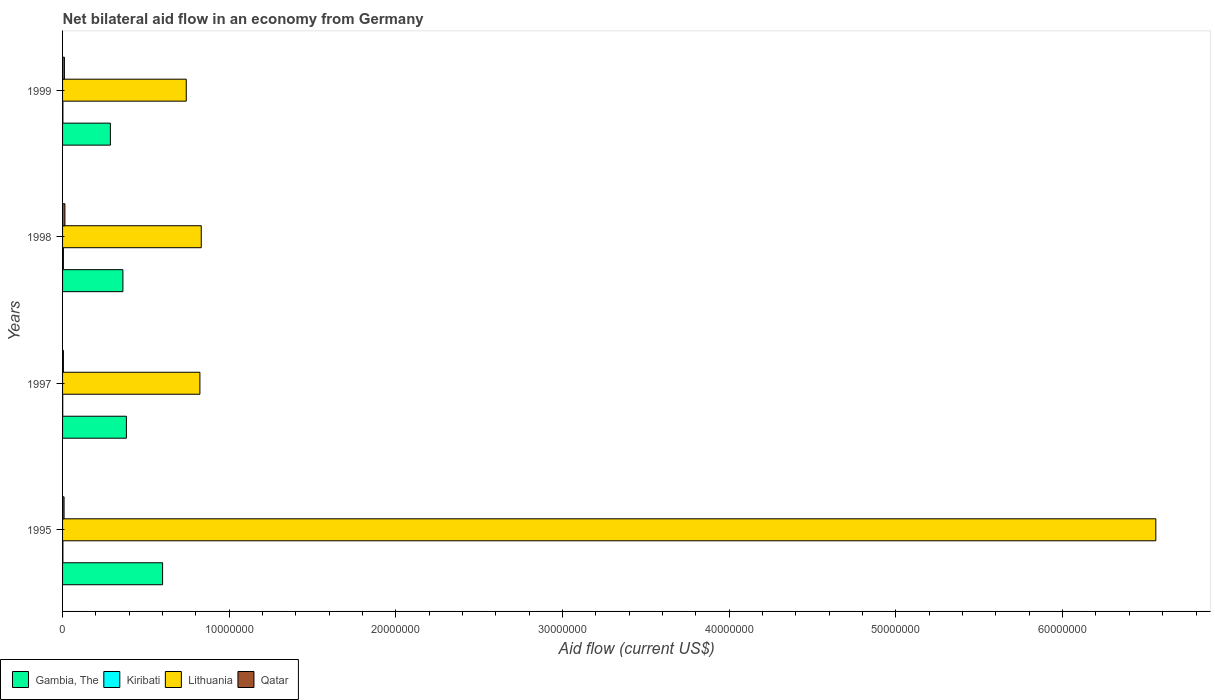How many groups of bars are there?
Give a very brief answer. 4. How many bars are there on the 3rd tick from the bottom?
Your response must be concise. 4. What is the label of the 4th group of bars from the top?
Give a very brief answer. 1995. In how many cases, is the number of bars for a given year not equal to the number of legend labels?
Ensure brevity in your answer.  0. What is the net bilateral aid flow in Kiribati in 1995?
Your response must be concise. 2.00e+04. In which year was the net bilateral aid flow in Lithuania maximum?
Keep it short and to the point. 1995. In which year was the net bilateral aid flow in Kiribati minimum?
Offer a very short reply. 1997. What is the total net bilateral aid flow in Gambia, The in the graph?
Your answer should be very brief. 1.63e+07. What is the difference between the net bilateral aid flow in Gambia, The in 1995 and that in 1999?
Give a very brief answer. 3.13e+06. What is the average net bilateral aid flow in Lithuania per year?
Provide a short and direct response. 2.24e+07. In the year 1998, what is the difference between the net bilateral aid flow in Lithuania and net bilateral aid flow in Qatar?
Your response must be concise. 8.18e+06. In how many years, is the net bilateral aid flow in Qatar greater than 4000000 US$?
Give a very brief answer. 0. What is the ratio of the net bilateral aid flow in Qatar in 1995 to that in 1997?
Provide a short and direct response. 1.8. Is the difference between the net bilateral aid flow in Lithuania in 1998 and 1999 greater than the difference between the net bilateral aid flow in Qatar in 1998 and 1999?
Offer a terse response. Yes. What is the difference between the highest and the second highest net bilateral aid flow in Lithuania?
Ensure brevity in your answer.  5.73e+07. What is the difference between the highest and the lowest net bilateral aid flow in Lithuania?
Keep it short and to the point. 5.82e+07. In how many years, is the net bilateral aid flow in Kiribati greater than the average net bilateral aid flow in Kiribati taken over all years?
Make the answer very short. 1. What does the 4th bar from the top in 1997 represents?
Provide a succinct answer. Gambia, The. What does the 4th bar from the bottom in 1998 represents?
Provide a short and direct response. Qatar. Is it the case that in every year, the sum of the net bilateral aid flow in Qatar and net bilateral aid flow in Gambia, The is greater than the net bilateral aid flow in Kiribati?
Provide a short and direct response. Yes. How many years are there in the graph?
Your answer should be very brief. 4. What is the difference between two consecutive major ticks on the X-axis?
Your answer should be very brief. 1.00e+07. Are the values on the major ticks of X-axis written in scientific E-notation?
Provide a succinct answer. No. Does the graph contain any zero values?
Keep it short and to the point. No. Does the graph contain grids?
Give a very brief answer. No. How many legend labels are there?
Your answer should be very brief. 4. What is the title of the graph?
Ensure brevity in your answer.  Net bilateral aid flow in an economy from Germany. What is the label or title of the X-axis?
Offer a very short reply. Aid flow (current US$). What is the Aid flow (current US$) in Lithuania in 1995?
Your answer should be compact. 6.56e+07. What is the Aid flow (current US$) of Qatar in 1995?
Your answer should be compact. 9.00e+04. What is the Aid flow (current US$) of Gambia, The in 1997?
Ensure brevity in your answer.  3.83e+06. What is the Aid flow (current US$) in Lithuania in 1997?
Your response must be concise. 8.24e+06. What is the Aid flow (current US$) of Gambia, The in 1998?
Your answer should be very brief. 3.62e+06. What is the Aid flow (current US$) in Kiribati in 1998?
Your answer should be very brief. 5.00e+04. What is the Aid flow (current US$) of Lithuania in 1998?
Provide a short and direct response. 8.32e+06. What is the Aid flow (current US$) of Qatar in 1998?
Make the answer very short. 1.40e+05. What is the Aid flow (current US$) in Gambia, The in 1999?
Your answer should be very brief. 2.87e+06. What is the Aid flow (current US$) in Lithuania in 1999?
Your response must be concise. 7.42e+06. Across all years, what is the maximum Aid flow (current US$) in Lithuania?
Keep it short and to the point. 6.56e+07. Across all years, what is the minimum Aid flow (current US$) in Gambia, The?
Keep it short and to the point. 2.87e+06. Across all years, what is the minimum Aid flow (current US$) in Kiribati?
Give a very brief answer. 10000. Across all years, what is the minimum Aid flow (current US$) of Lithuania?
Offer a terse response. 7.42e+06. Across all years, what is the minimum Aid flow (current US$) of Qatar?
Offer a very short reply. 5.00e+04. What is the total Aid flow (current US$) in Gambia, The in the graph?
Ensure brevity in your answer.  1.63e+07. What is the total Aid flow (current US$) of Kiribati in the graph?
Your answer should be very brief. 1.00e+05. What is the total Aid flow (current US$) of Lithuania in the graph?
Give a very brief answer. 8.96e+07. What is the total Aid flow (current US$) in Qatar in the graph?
Give a very brief answer. 3.90e+05. What is the difference between the Aid flow (current US$) in Gambia, The in 1995 and that in 1997?
Your response must be concise. 2.17e+06. What is the difference between the Aid flow (current US$) of Lithuania in 1995 and that in 1997?
Your answer should be compact. 5.74e+07. What is the difference between the Aid flow (current US$) in Qatar in 1995 and that in 1997?
Give a very brief answer. 4.00e+04. What is the difference between the Aid flow (current US$) in Gambia, The in 1995 and that in 1998?
Offer a very short reply. 2.38e+06. What is the difference between the Aid flow (current US$) in Lithuania in 1995 and that in 1998?
Provide a short and direct response. 5.73e+07. What is the difference between the Aid flow (current US$) of Qatar in 1995 and that in 1998?
Offer a very short reply. -5.00e+04. What is the difference between the Aid flow (current US$) in Gambia, The in 1995 and that in 1999?
Give a very brief answer. 3.13e+06. What is the difference between the Aid flow (current US$) in Lithuania in 1995 and that in 1999?
Offer a terse response. 5.82e+07. What is the difference between the Aid flow (current US$) in Gambia, The in 1997 and that in 1999?
Make the answer very short. 9.60e+05. What is the difference between the Aid flow (current US$) in Lithuania in 1997 and that in 1999?
Offer a very short reply. 8.20e+05. What is the difference between the Aid flow (current US$) of Qatar in 1997 and that in 1999?
Give a very brief answer. -6.00e+04. What is the difference between the Aid flow (current US$) in Gambia, The in 1998 and that in 1999?
Your answer should be very brief. 7.50e+05. What is the difference between the Aid flow (current US$) of Gambia, The in 1995 and the Aid flow (current US$) of Kiribati in 1997?
Your response must be concise. 5.99e+06. What is the difference between the Aid flow (current US$) in Gambia, The in 1995 and the Aid flow (current US$) in Lithuania in 1997?
Your answer should be compact. -2.24e+06. What is the difference between the Aid flow (current US$) of Gambia, The in 1995 and the Aid flow (current US$) of Qatar in 1997?
Keep it short and to the point. 5.95e+06. What is the difference between the Aid flow (current US$) of Kiribati in 1995 and the Aid flow (current US$) of Lithuania in 1997?
Your answer should be compact. -8.22e+06. What is the difference between the Aid flow (current US$) of Lithuania in 1995 and the Aid flow (current US$) of Qatar in 1997?
Your answer should be compact. 6.55e+07. What is the difference between the Aid flow (current US$) of Gambia, The in 1995 and the Aid flow (current US$) of Kiribati in 1998?
Provide a short and direct response. 5.95e+06. What is the difference between the Aid flow (current US$) of Gambia, The in 1995 and the Aid flow (current US$) of Lithuania in 1998?
Provide a succinct answer. -2.32e+06. What is the difference between the Aid flow (current US$) in Gambia, The in 1995 and the Aid flow (current US$) in Qatar in 1998?
Your response must be concise. 5.86e+06. What is the difference between the Aid flow (current US$) of Kiribati in 1995 and the Aid flow (current US$) of Lithuania in 1998?
Make the answer very short. -8.30e+06. What is the difference between the Aid flow (current US$) of Lithuania in 1995 and the Aid flow (current US$) of Qatar in 1998?
Make the answer very short. 6.54e+07. What is the difference between the Aid flow (current US$) in Gambia, The in 1995 and the Aid flow (current US$) in Kiribati in 1999?
Provide a short and direct response. 5.98e+06. What is the difference between the Aid flow (current US$) in Gambia, The in 1995 and the Aid flow (current US$) in Lithuania in 1999?
Make the answer very short. -1.42e+06. What is the difference between the Aid flow (current US$) in Gambia, The in 1995 and the Aid flow (current US$) in Qatar in 1999?
Give a very brief answer. 5.89e+06. What is the difference between the Aid flow (current US$) of Kiribati in 1995 and the Aid flow (current US$) of Lithuania in 1999?
Ensure brevity in your answer.  -7.40e+06. What is the difference between the Aid flow (current US$) of Lithuania in 1995 and the Aid flow (current US$) of Qatar in 1999?
Your answer should be very brief. 6.55e+07. What is the difference between the Aid flow (current US$) of Gambia, The in 1997 and the Aid flow (current US$) of Kiribati in 1998?
Offer a very short reply. 3.78e+06. What is the difference between the Aid flow (current US$) of Gambia, The in 1997 and the Aid flow (current US$) of Lithuania in 1998?
Provide a succinct answer. -4.49e+06. What is the difference between the Aid flow (current US$) in Gambia, The in 1997 and the Aid flow (current US$) in Qatar in 1998?
Give a very brief answer. 3.69e+06. What is the difference between the Aid flow (current US$) in Kiribati in 1997 and the Aid flow (current US$) in Lithuania in 1998?
Keep it short and to the point. -8.31e+06. What is the difference between the Aid flow (current US$) in Lithuania in 1997 and the Aid flow (current US$) in Qatar in 1998?
Offer a very short reply. 8.10e+06. What is the difference between the Aid flow (current US$) of Gambia, The in 1997 and the Aid flow (current US$) of Kiribati in 1999?
Offer a very short reply. 3.81e+06. What is the difference between the Aid flow (current US$) in Gambia, The in 1997 and the Aid flow (current US$) in Lithuania in 1999?
Your response must be concise. -3.59e+06. What is the difference between the Aid flow (current US$) of Gambia, The in 1997 and the Aid flow (current US$) of Qatar in 1999?
Offer a terse response. 3.72e+06. What is the difference between the Aid flow (current US$) of Kiribati in 1997 and the Aid flow (current US$) of Lithuania in 1999?
Offer a very short reply. -7.41e+06. What is the difference between the Aid flow (current US$) of Kiribati in 1997 and the Aid flow (current US$) of Qatar in 1999?
Offer a terse response. -1.00e+05. What is the difference between the Aid flow (current US$) in Lithuania in 1997 and the Aid flow (current US$) in Qatar in 1999?
Ensure brevity in your answer.  8.13e+06. What is the difference between the Aid flow (current US$) of Gambia, The in 1998 and the Aid flow (current US$) of Kiribati in 1999?
Make the answer very short. 3.60e+06. What is the difference between the Aid flow (current US$) in Gambia, The in 1998 and the Aid flow (current US$) in Lithuania in 1999?
Provide a succinct answer. -3.80e+06. What is the difference between the Aid flow (current US$) in Gambia, The in 1998 and the Aid flow (current US$) in Qatar in 1999?
Give a very brief answer. 3.51e+06. What is the difference between the Aid flow (current US$) in Kiribati in 1998 and the Aid flow (current US$) in Lithuania in 1999?
Your answer should be very brief. -7.37e+06. What is the difference between the Aid flow (current US$) of Kiribati in 1998 and the Aid flow (current US$) of Qatar in 1999?
Provide a succinct answer. -6.00e+04. What is the difference between the Aid flow (current US$) of Lithuania in 1998 and the Aid flow (current US$) of Qatar in 1999?
Keep it short and to the point. 8.21e+06. What is the average Aid flow (current US$) of Gambia, The per year?
Offer a terse response. 4.08e+06. What is the average Aid flow (current US$) of Kiribati per year?
Offer a terse response. 2.50e+04. What is the average Aid flow (current US$) of Lithuania per year?
Your response must be concise. 2.24e+07. What is the average Aid flow (current US$) of Qatar per year?
Ensure brevity in your answer.  9.75e+04. In the year 1995, what is the difference between the Aid flow (current US$) of Gambia, The and Aid flow (current US$) of Kiribati?
Your response must be concise. 5.98e+06. In the year 1995, what is the difference between the Aid flow (current US$) in Gambia, The and Aid flow (current US$) in Lithuania?
Give a very brief answer. -5.96e+07. In the year 1995, what is the difference between the Aid flow (current US$) in Gambia, The and Aid flow (current US$) in Qatar?
Your response must be concise. 5.91e+06. In the year 1995, what is the difference between the Aid flow (current US$) in Kiribati and Aid flow (current US$) in Lithuania?
Offer a terse response. -6.56e+07. In the year 1995, what is the difference between the Aid flow (current US$) in Kiribati and Aid flow (current US$) in Qatar?
Offer a very short reply. -7.00e+04. In the year 1995, what is the difference between the Aid flow (current US$) of Lithuania and Aid flow (current US$) of Qatar?
Ensure brevity in your answer.  6.55e+07. In the year 1997, what is the difference between the Aid flow (current US$) of Gambia, The and Aid flow (current US$) of Kiribati?
Provide a succinct answer. 3.82e+06. In the year 1997, what is the difference between the Aid flow (current US$) of Gambia, The and Aid flow (current US$) of Lithuania?
Offer a terse response. -4.41e+06. In the year 1997, what is the difference between the Aid flow (current US$) of Gambia, The and Aid flow (current US$) of Qatar?
Offer a very short reply. 3.78e+06. In the year 1997, what is the difference between the Aid flow (current US$) of Kiribati and Aid flow (current US$) of Lithuania?
Your response must be concise. -8.23e+06. In the year 1997, what is the difference between the Aid flow (current US$) in Kiribati and Aid flow (current US$) in Qatar?
Keep it short and to the point. -4.00e+04. In the year 1997, what is the difference between the Aid flow (current US$) of Lithuania and Aid flow (current US$) of Qatar?
Your answer should be compact. 8.19e+06. In the year 1998, what is the difference between the Aid flow (current US$) in Gambia, The and Aid flow (current US$) in Kiribati?
Offer a terse response. 3.57e+06. In the year 1998, what is the difference between the Aid flow (current US$) of Gambia, The and Aid flow (current US$) of Lithuania?
Provide a succinct answer. -4.70e+06. In the year 1998, what is the difference between the Aid flow (current US$) of Gambia, The and Aid flow (current US$) of Qatar?
Your response must be concise. 3.48e+06. In the year 1998, what is the difference between the Aid flow (current US$) of Kiribati and Aid flow (current US$) of Lithuania?
Make the answer very short. -8.27e+06. In the year 1998, what is the difference between the Aid flow (current US$) of Kiribati and Aid flow (current US$) of Qatar?
Provide a succinct answer. -9.00e+04. In the year 1998, what is the difference between the Aid flow (current US$) in Lithuania and Aid flow (current US$) in Qatar?
Offer a terse response. 8.18e+06. In the year 1999, what is the difference between the Aid flow (current US$) in Gambia, The and Aid flow (current US$) in Kiribati?
Provide a short and direct response. 2.85e+06. In the year 1999, what is the difference between the Aid flow (current US$) of Gambia, The and Aid flow (current US$) of Lithuania?
Give a very brief answer. -4.55e+06. In the year 1999, what is the difference between the Aid flow (current US$) of Gambia, The and Aid flow (current US$) of Qatar?
Offer a terse response. 2.76e+06. In the year 1999, what is the difference between the Aid flow (current US$) in Kiribati and Aid flow (current US$) in Lithuania?
Ensure brevity in your answer.  -7.40e+06. In the year 1999, what is the difference between the Aid flow (current US$) of Kiribati and Aid flow (current US$) of Qatar?
Make the answer very short. -9.00e+04. In the year 1999, what is the difference between the Aid flow (current US$) in Lithuania and Aid flow (current US$) in Qatar?
Provide a succinct answer. 7.31e+06. What is the ratio of the Aid flow (current US$) in Gambia, The in 1995 to that in 1997?
Your response must be concise. 1.57. What is the ratio of the Aid flow (current US$) in Kiribati in 1995 to that in 1997?
Provide a short and direct response. 2. What is the ratio of the Aid flow (current US$) in Lithuania in 1995 to that in 1997?
Ensure brevity in your answer.  7.96. What is the ratio of the Aid flow (current US$) in Qatar in 1995 to that in 1997?
Give a very brief answer. 1.8. What is the ratio of the Aid flow (current US$) of Gambia, The in 1995 to that in 1998?
Offer a very short reply. 1.66. What is the ratio of the Aid flow (current US$) of Lithuania in 1995 to that in 1998?
Keep it short and to the point. 7.88. What is the ratio of the Aid flow (current US$) of Qatar in 1995 to that in 1998?
Offer a very short reply. 0.64. What is the ratio of the Aid flow (current US$) in Gambia, The in 1995 to that in 1999?
Provide a succinct answer. 2.09. What is the ratio of the Aid flow (current US$) in Lithuania in 1995 to that in 1999?
Offer a very short reply. 8.84. What is the ratio of the Aid flow (current US$) in Qatar in 1995 to that in 1999?
Offer a very short reply. 0.82. What is the ratio of the Aid flow (current US$) of Gambia, The in 1997 to that in 1998?
Offer a terse response. 1.06. What is the ratio of the Aid flow (current US$) of Kiribati in 1997 to that in 1998?
Your response must be concise. 0.2. What is the ratio of the Aid flow (current US$) in Lithuania in 1997 to that in 1998?
Provide a succinct answer. 0.99. What is the ratio of the Aid flow (current US$) in Qatar in 1997 to that in 1998?
Your answer should be compact. 0.36. What is the ratio of the Aid flow (current US$) of Gambia, The in 1997 to that in 1999?
Give a very brief answer. 1.33. What is the ratio of the Aid flow (current US$) in Kiribati in 1997 to that in 1999?
Offer a very short reply. 0.5. What is the ratio of the Aid flow (current US$) in Lithuania in 1997 to that in 1999?
Keep it short and to the point. 1.11. What is the ratio of the Aid flow (current US$) of Qatar in 1997 to that in 1999?
Give a very brief answer. 0.45. What is the ratio of the Aid flow (current US$) of Gambia, The in 1998 to that in 1999?
Your answer should be very brief. 1.26. What is the ratio of the Aid flow (current US$) in Kiribati in 1998 to that in 1999?
Offer a terse response. 2.5. What is the ratio of the Aid flow (current US$) of Lithuania in 1998 to that in 1999?
Your answer should be compact. 1.12. What is the ratio of the Aid flow (current US$) in Qatar in 1998 to that in 1999?
Ensure brevity in your answer.  1.27. What is the difference between the highest and the second highest Aid flow (current US$) in Gambia, The?
Your answer should be compact. 2.17e+06. What is the difference between the highest and the second highest Aid flow (current US$) of Kiribati?
Keep it short and to the point. 3.00e+04. What is the difference between the highest and the second highest Aid flow (current US$) in Lithuania?
Provide a short and direct response. 5.73e+07. What is the difference between the highest and the lowest Aid flow (current US$) of Gambia, The?
Ensure brevity in your answer.  3.13e+06. What is the difference between the highest and the lowest Aid flow (current US$) in Kiribati?
Ensure brevity in your answer.  4.00e+04. What is the difference between the highest and the lowest Aid flow (current US$) of Lithuania?
Provide a short and direct response. 5.82e+07. What is the difference between the highest and the lowest Aid flow (current US$) in Qatar?
Give a very brief answer. 9.00e+04. 